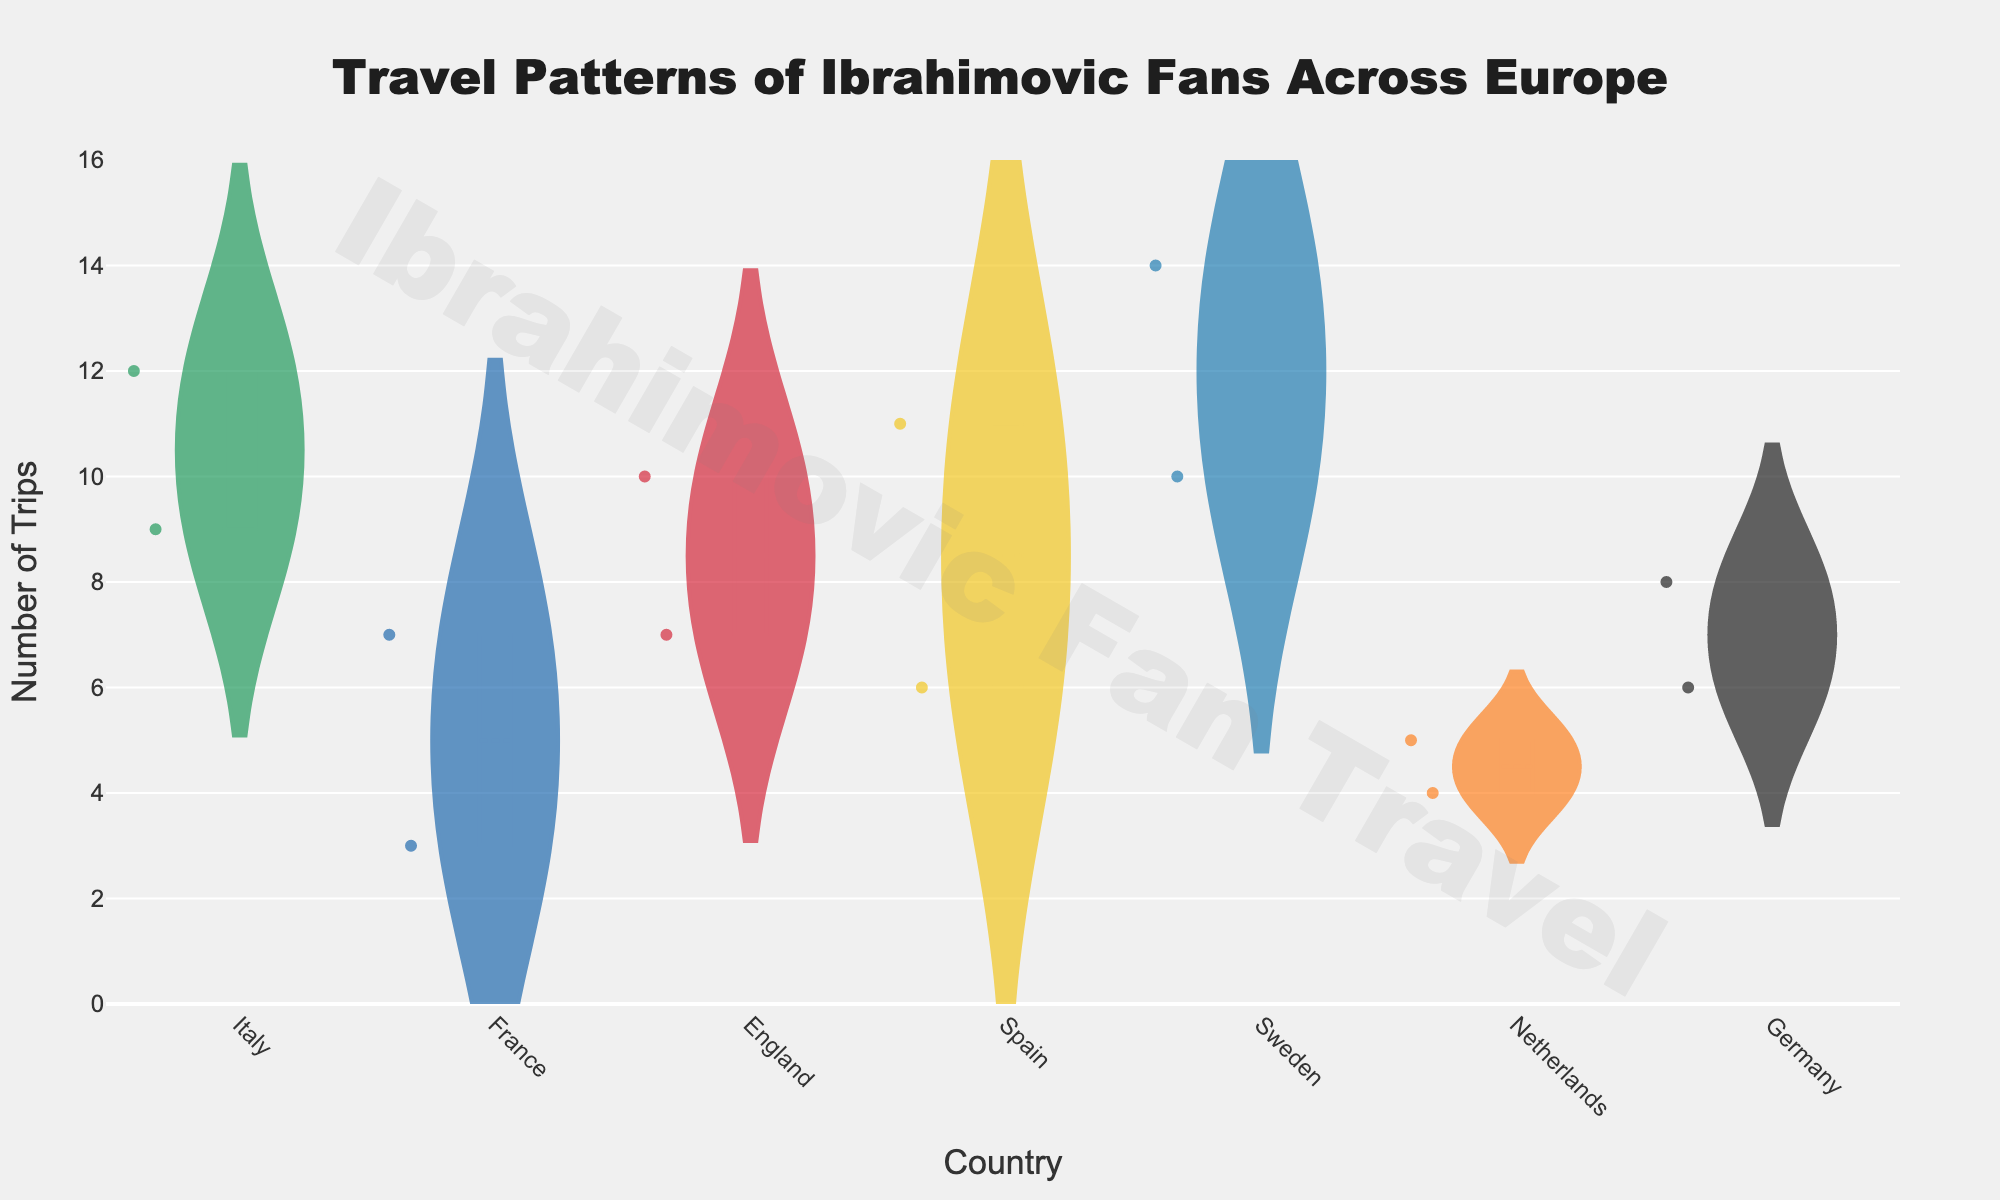How many trips did fans make to Milan? Check the box plot for Italy and see the value corresponding to Milan on the y-axis.
Answer: 12 Which country has the highest mean number of trips? Examine the meanline (horizontal line) within each country's plot and determine which one is positioned highest.
Answer: Sweden Between Munich and Berlin, which city has fewer trips made by fans? Compare the number of trips for Munich and Berlin in the Germany plot.
Answer: Berlin What's the total number of trips made to all cities in France? Add the number of trips to Paris (7) and Lyon (3).
Answer: 10 Compare the median number of trips between Spain and Netherlands. Look at the middle line inside the violins for Spain and Netherlands and compare their positions.
Answer: Spain has a higher median Which country shows the greatest variety of trips (i.e., the widest range)? Observe the length of the violin plots for each country and determine which one spans the largest vertical range.
Answer: Sweden Is Stockholm or Gothenburg more frequently visited by fans? Check the values in the Sweden plot and compare the number of trips for Stockholm and Gothenburg.
Answer: Stockholm How many countries have at least one data point above 10 trips? Count the countries whose violin plots have points or the maximum length above the 10 trip mark.
Answer: 5 Which country has the smallest number of trips for the least visited city? Find the country with the least number of trips on the lower end of the violin, and identify the smallest value within that country.
Answer: Netherlands 